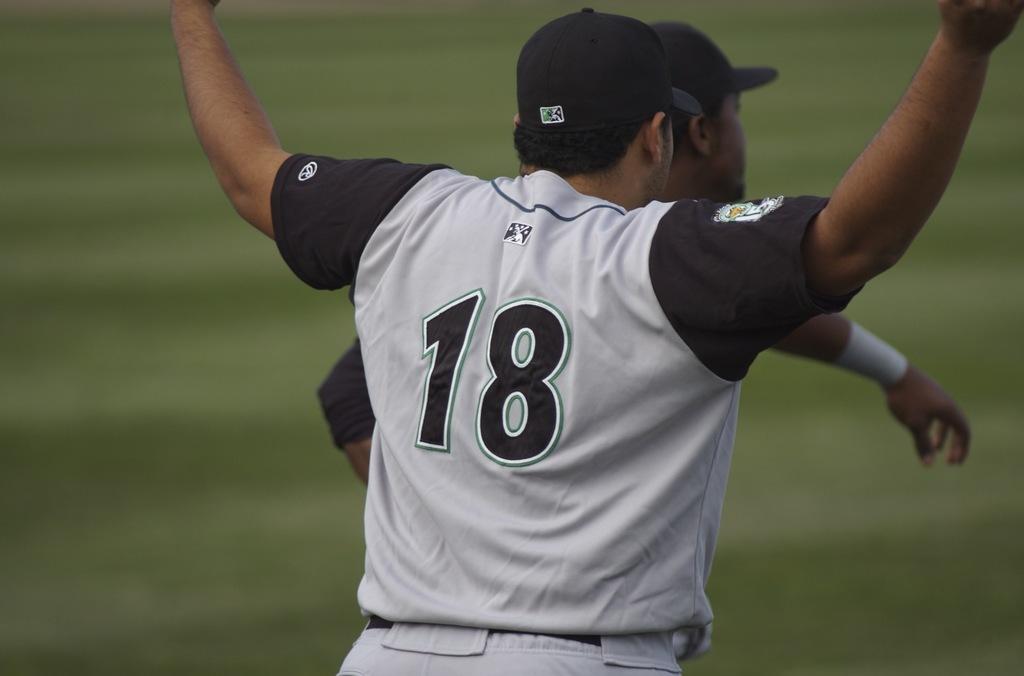What number is the baseball player?
Make the answer very short. 18. 